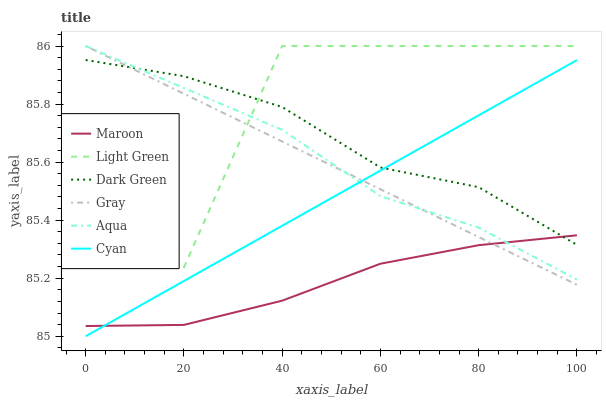Does Maroon have the minimum area under the curve?
Answer yes or no. Yes. Does Light Green have the maximum area under the curve?
Answer yes or no. Yes. Does Aqua have the minimum area under the curve?
Answer yes or no. No. Does Aqua have the maximum area under the curve?
Answer yes or no. No. Is Gray the smoothest?
Answer yes or no. Yes. Is Light Green the roughest?
Answer yes or no. Yes. Is Aqua the smoothest?
Answer yes or no. No. Is Aqua the roughest?
Answer yes or no. No. Does Cyan have the lowest value?
Answer yes or no. Yes. Does Aqua have the lowest value?
Answer yes or no. No. Does Light Green have the highest value?
Answer yes or no. Yes. Does Maroon have the highest value?
Answer yes or no. No. Is Cyan less than Light Green?
Answer yes or no. Yes. Is Light Green greater than Cyan?
Answer yes or no. Yes. Does Dark Green intersect Maroon?
Answer yes or no. Yes. Is Dark Green less than Maroon?
Answer yes or no. No. Is Dark Green greater than Maroon?
Answer yes or no. No. Does Cyan intersect Light Green?
Answer yes or no. No. 